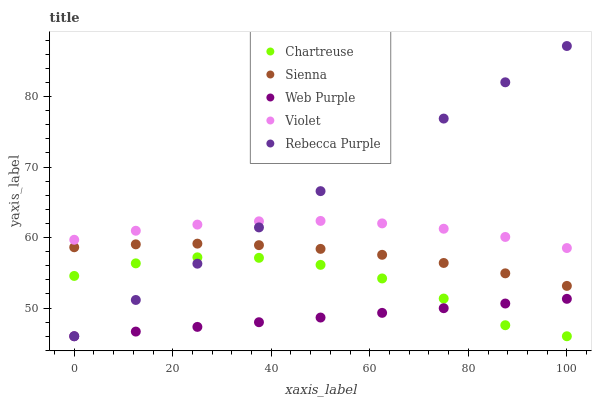Does Web Purple have the minimum area under the curve?
Answer yes or no. Yes. Does Rebecca Purple have the maximum area under the curve?
Answer yes or no. Yes. Does Chartreuse have the minimum area under the curve?
Answer yes or no. No. Does Chartreuse have the maximum area under the curve?
Answer yes or no. No. Is Web Purple the smoothest?
Answer yes or no. Yes. Is Chartreuse the roughest?
Answer yes or no. Yes. Is Chartreuse the smoothest?
Answer yes or no. No. Is Web Purple the roughest?
Answer yes or no. No. Does Chartreuse have the lowest value?
Answer yes or no. Yes. Does Violet have the lowest value?
Answer yes or no. No. Does Rebecca Purple have the highest value?
Answer yes or no. Yes. Does Chartreuse have the highest value?
Answer yes or no. No. Is Chartreuse less than Sienna?
Answer yes or no. Yes. Is Violet greater than Chartreuse?
Answer yes or no. Yes. Does Chartreuse intersect Rebecca Purple?
Answer yes or no. Yes. Is Chartreuse less than Rebecca Purple?
Answer yes or no. No. Is Chartreuse greater than Rebecca Purple?
Answer yes or no. No. Does Chartreuse intersect Sienna?
Answer yes or no. No. 